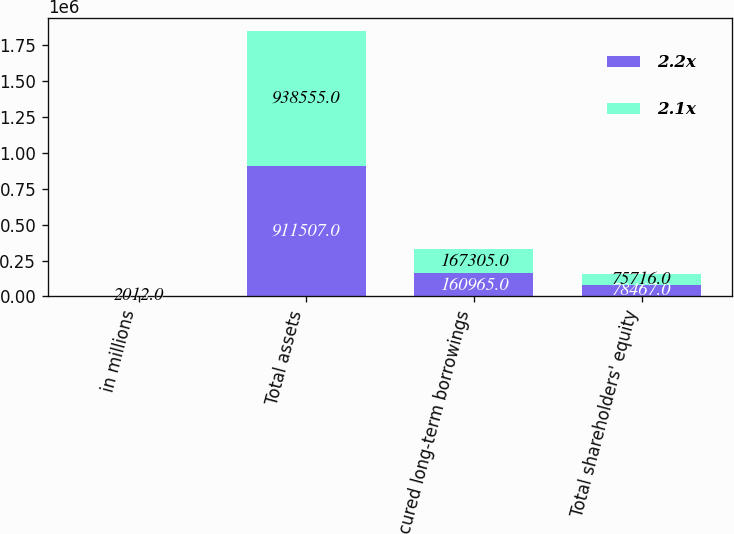<chart> <loc_0><loc_0><loc_500><loc_500><stacked_bar_chart><ecel><fcel>in millions<fcel>Total assets<fcel>Unsecured long-term borrowings<fcel>Total shareholders' equity<nl><fcel>2.2x<fcel>2013<fcel>911507<fcel>160965<fcel>78467<nl><fcel>2.1x<fcel>2012<fcel>938555<fcel>167305<fcel>75716<nl></chart> 